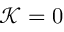Convert formula to latex. <formula><loc_0><loc_0><loc_500><loc_500>\mathcal { K } = 0</formula> 